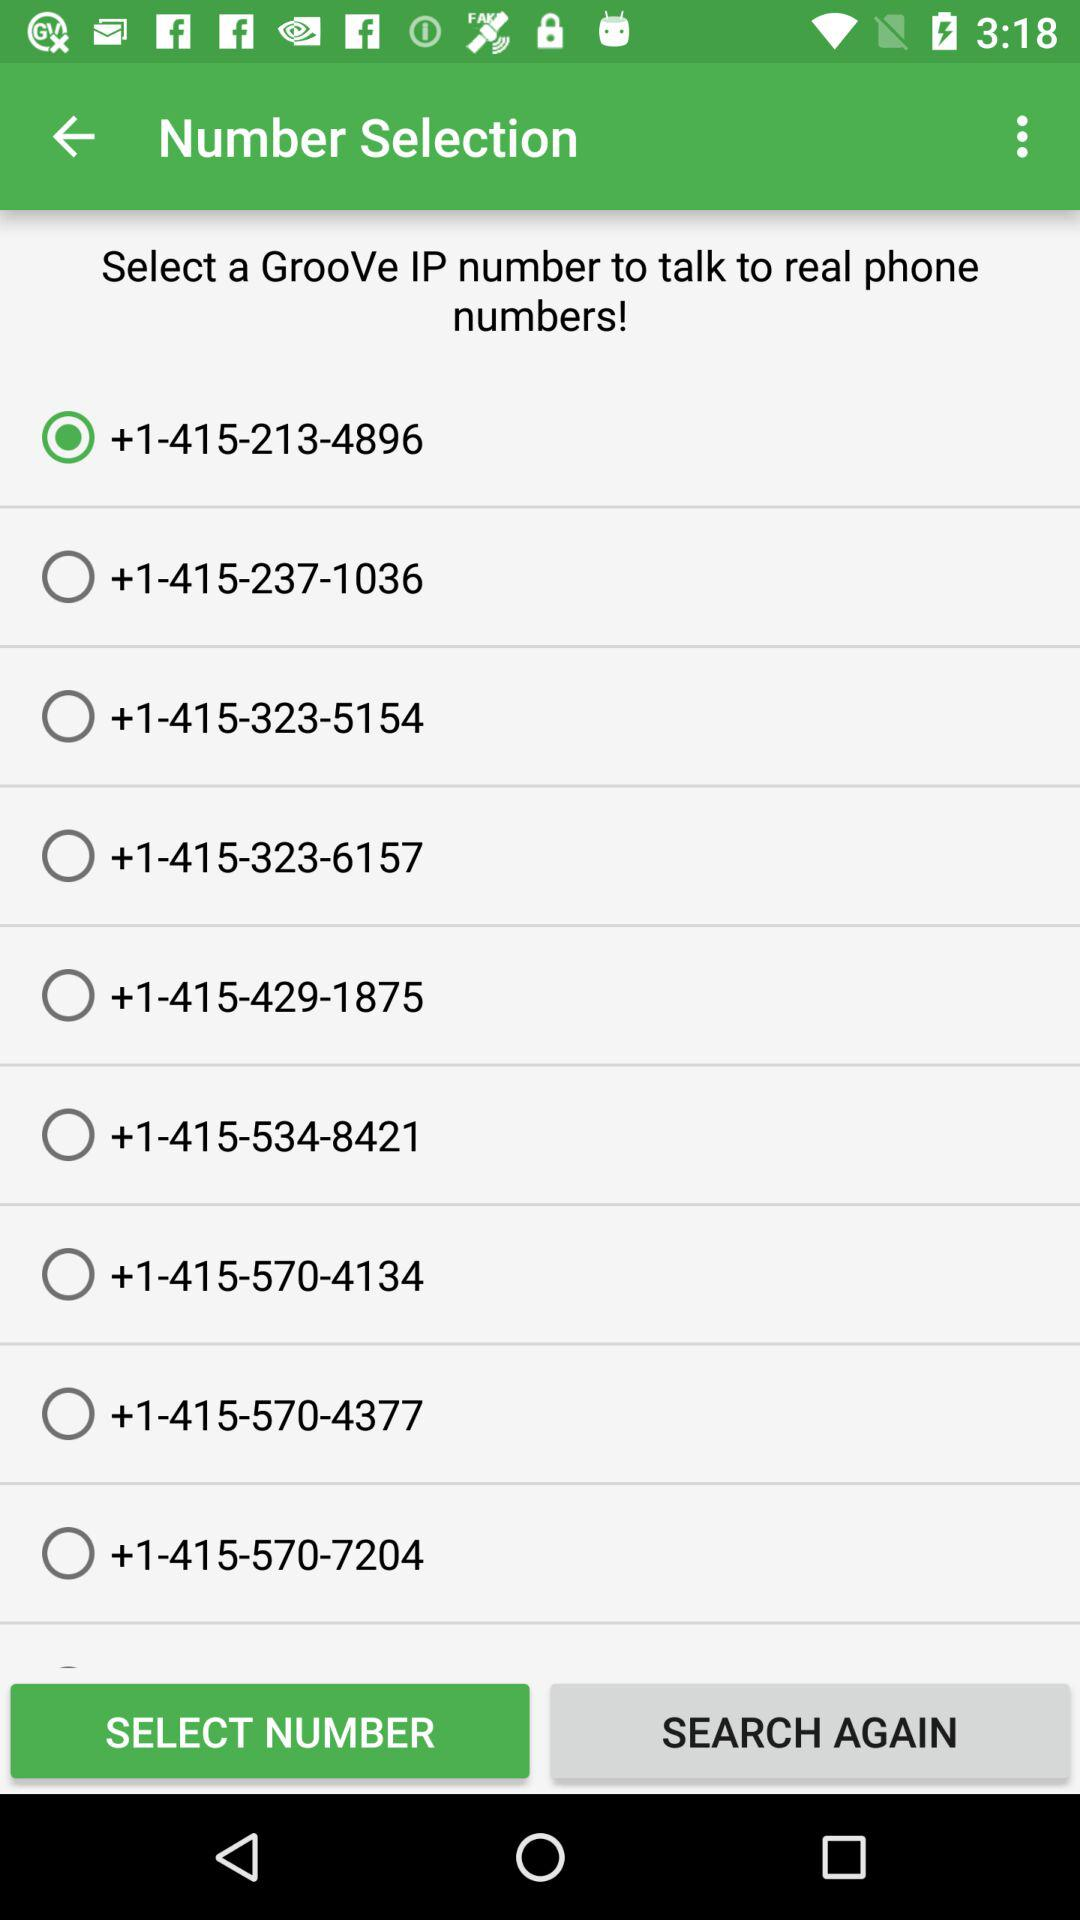Which number is selected? The selected number is +1-415-213-4896. 